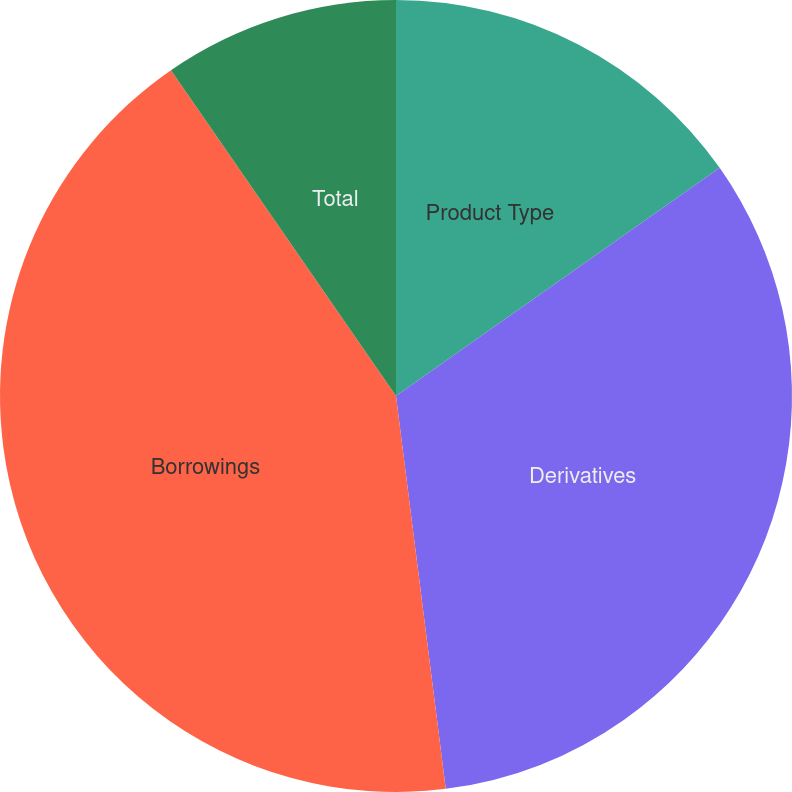Convert chart. <chart><loc_0><loc_0><loc_500><loc_500><pie_chart><fcel>Product Type<fcel>Derivatives<fcel>Borrowings<fcel>Total<nl><fcel>15.23%<fcel>32.77%<fcel>42.39%<fcel>9.62%<nl></chart> 